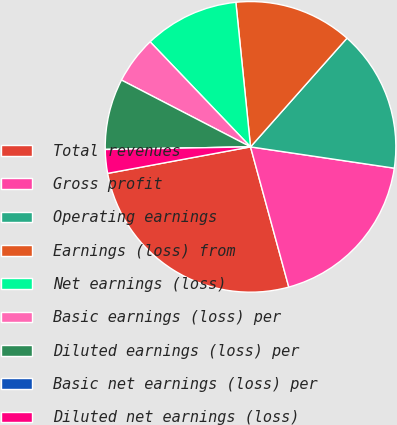<chart> <loc_0><loc_0><loc_500><loc_500><pie_chart><fcel>Total revenues<fcel>Gross profit<fcel>Operating earnings<fcel>Earnings (loss) from<fcel>Net earnings (loss)<fcel>Basic earnings (loss) per<fcel>Diluted earnings (loss) per<fcel>Basic net earnings (loss) per<fcel>Diluted net earnings (loss)<nl><fcel>26.32%<fcel>18.42%<fcel>15.79%<fcel>13.16%<fcel>10.53%<fcel>5.26%<fcel>7.89%<fcel>0.0%<fcel>2.63%<nl></chart> 